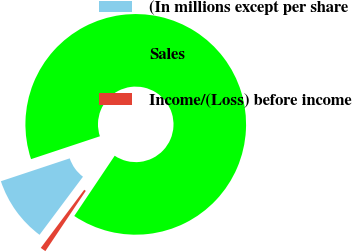Convert chart to OTSL. <chart><loc_0><loc_0><loc_500><loc_500><pie_chart><fcel>(In millions except per share<fcel>Sales<fcel>Income/(Loss) before income<nl><fcel>9.68%<fcel>89.52%<fcel>0.81%<nl></chart> 